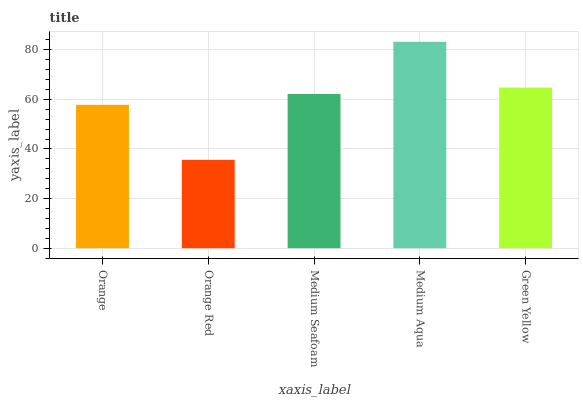Is Orange Red the minimum?
Answer yes or no. Yes. Is Medium Aqua the maximum?
Answer yes or no. Yes. Is Medium Seafoam the minimum?
Answer yes or no. No. Is Medium Seafoam the maximum?
Answer yes or no. No. Is Medium Seafoam greater than Orange Red?
Answer yes or no. Yes. Is Orange Red less than Medium Seafoam?
Answer yes or no. Yes. Is Orange Red greater than Medium Seafoam?
Answer yes or no. No. Is Medium Seafoam less than Orange Red?
Answer yes or no. No. Is Medium Seafoam the high median?
Answer yes or no. Yes. Is Medium Seafoam the low median?
Answer yes or no. Yes. Is Medium Aqua the high median?
Answer yes or no. No. Is Orange Red the low median?
Answer yes or no. No. 